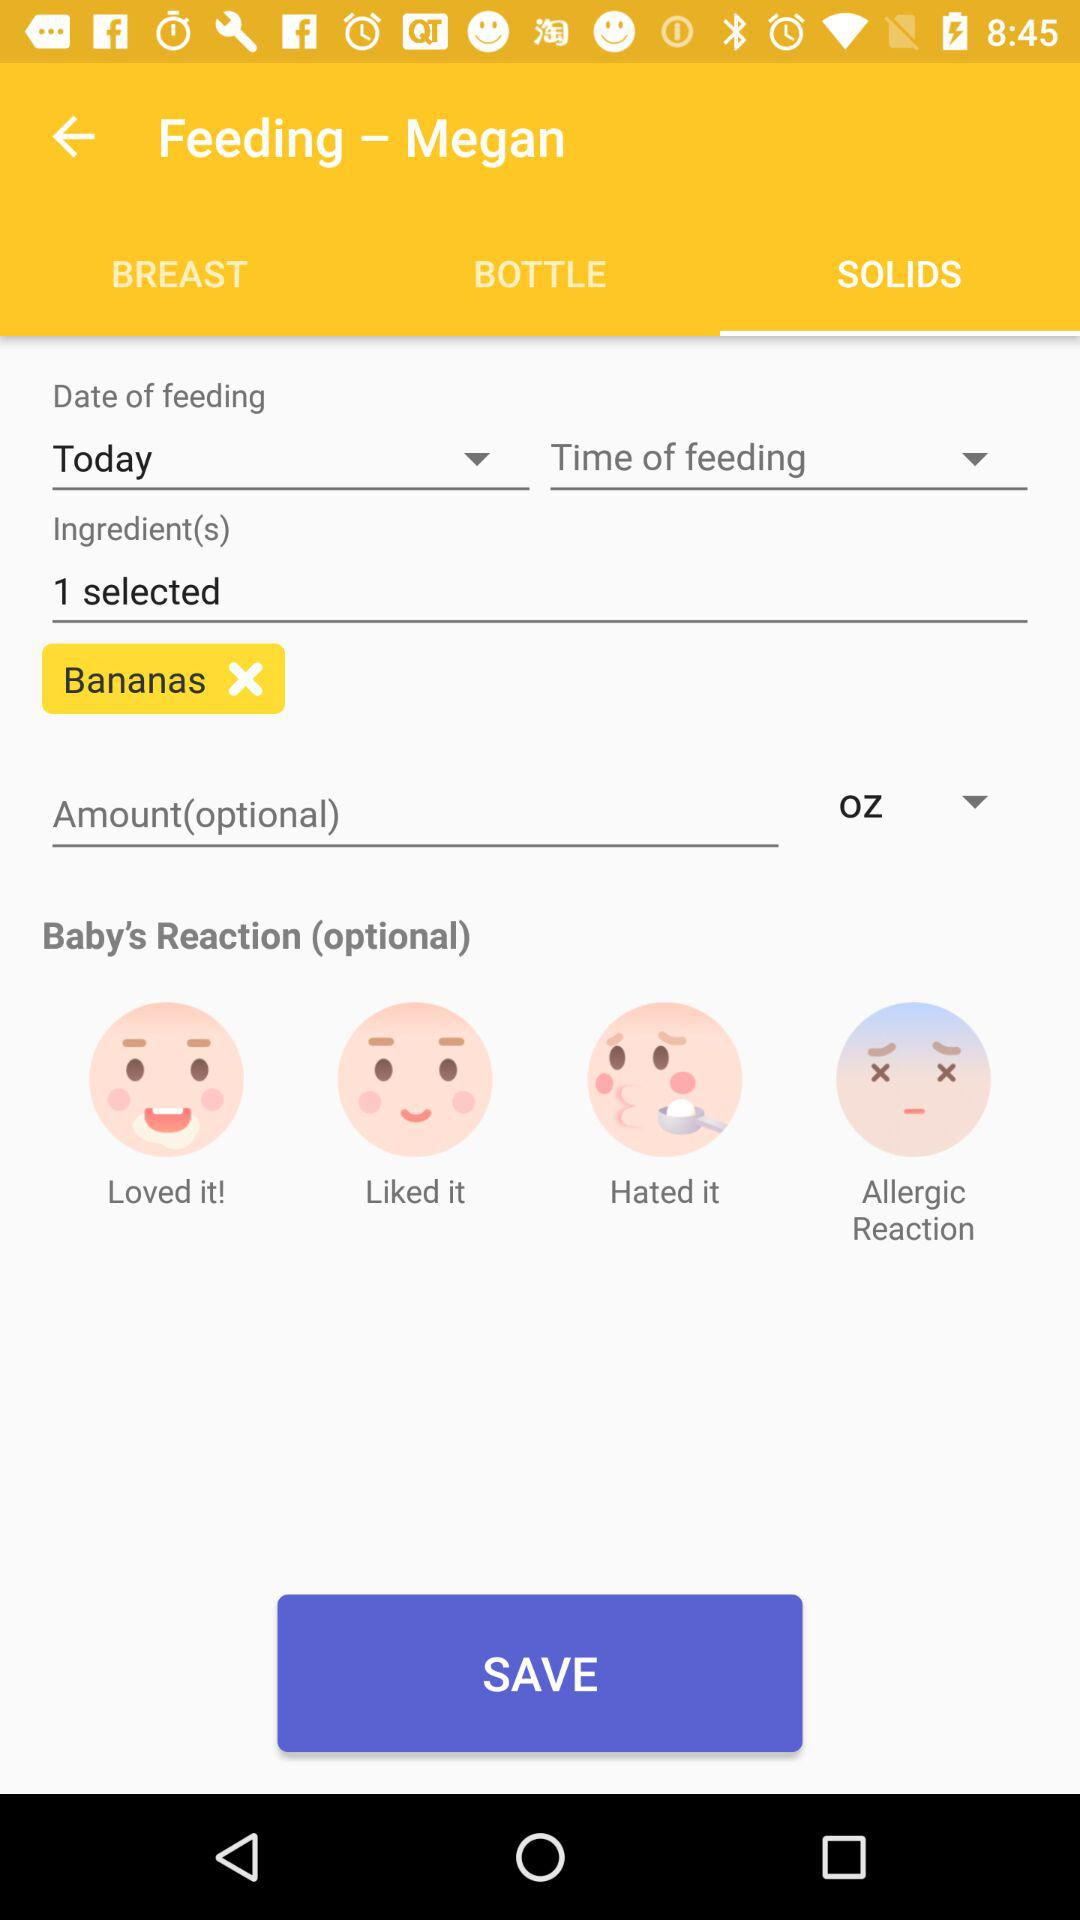What is the date of feeding? The date of feeding is "Today". 